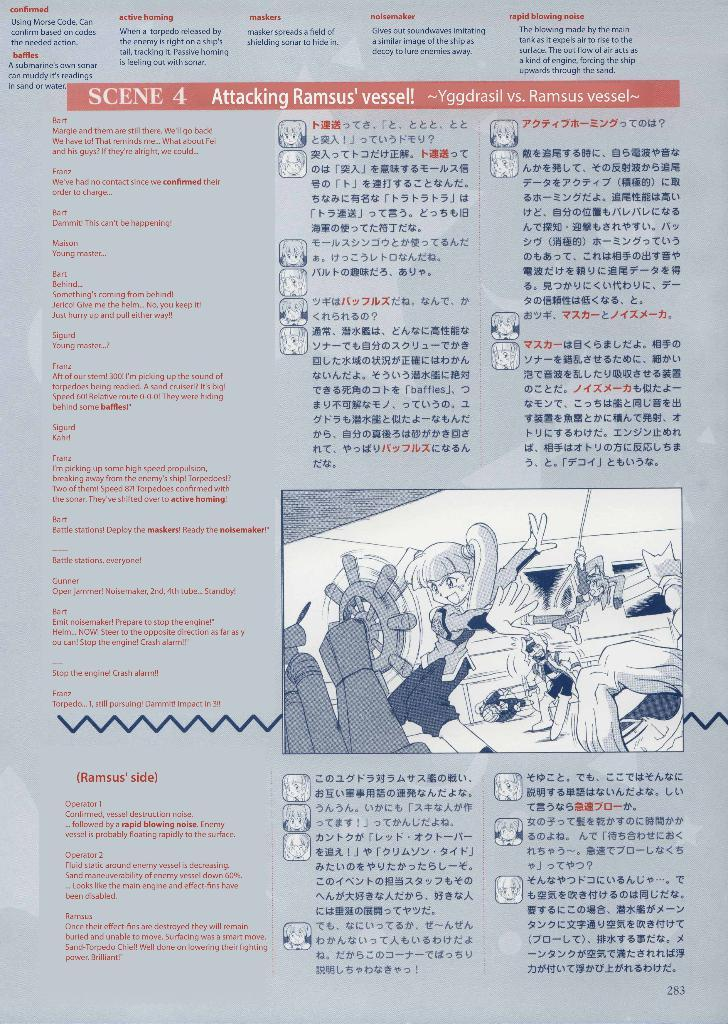<image>
Relay a brief, clear account of the picture shown. A grey poster with black writing titled, Scene 4 Attacking Ramsu' vessel. 